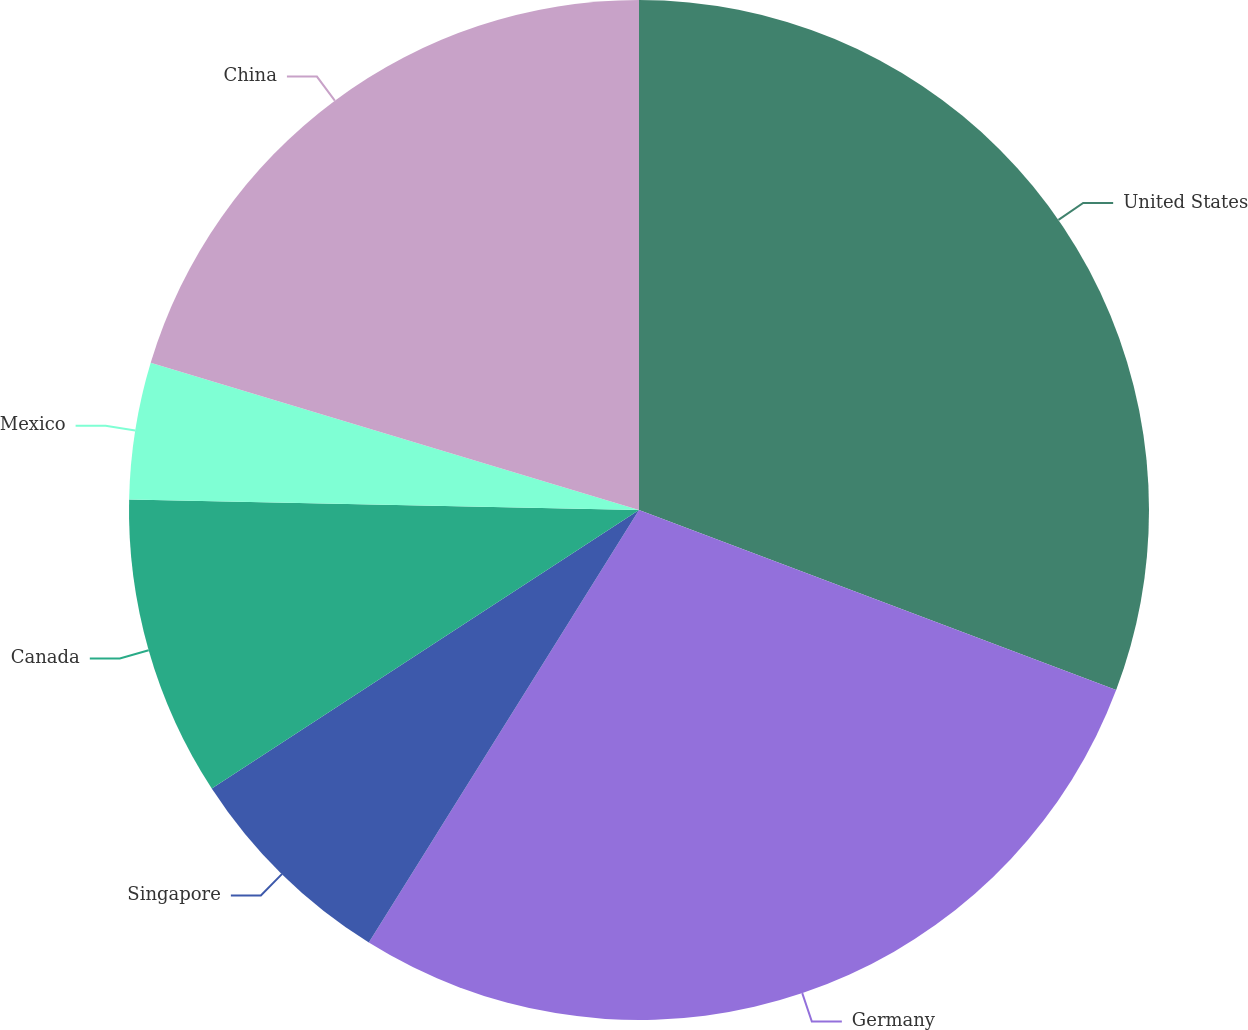Convert chart to OTSL. <chart><loc_0><loc_0><loc_500><loc_500><pie_chart><fcel>United States<fcel>Germany<fcel>Singapore<fcel>Canada<fcel>Mexico<fcel>China<nl><fcel>30.74%<fcel>28.14%<fcel>6.92%<fcel>9.52%<fcel>4.33%<fcel>20.34%<nl></chart> 